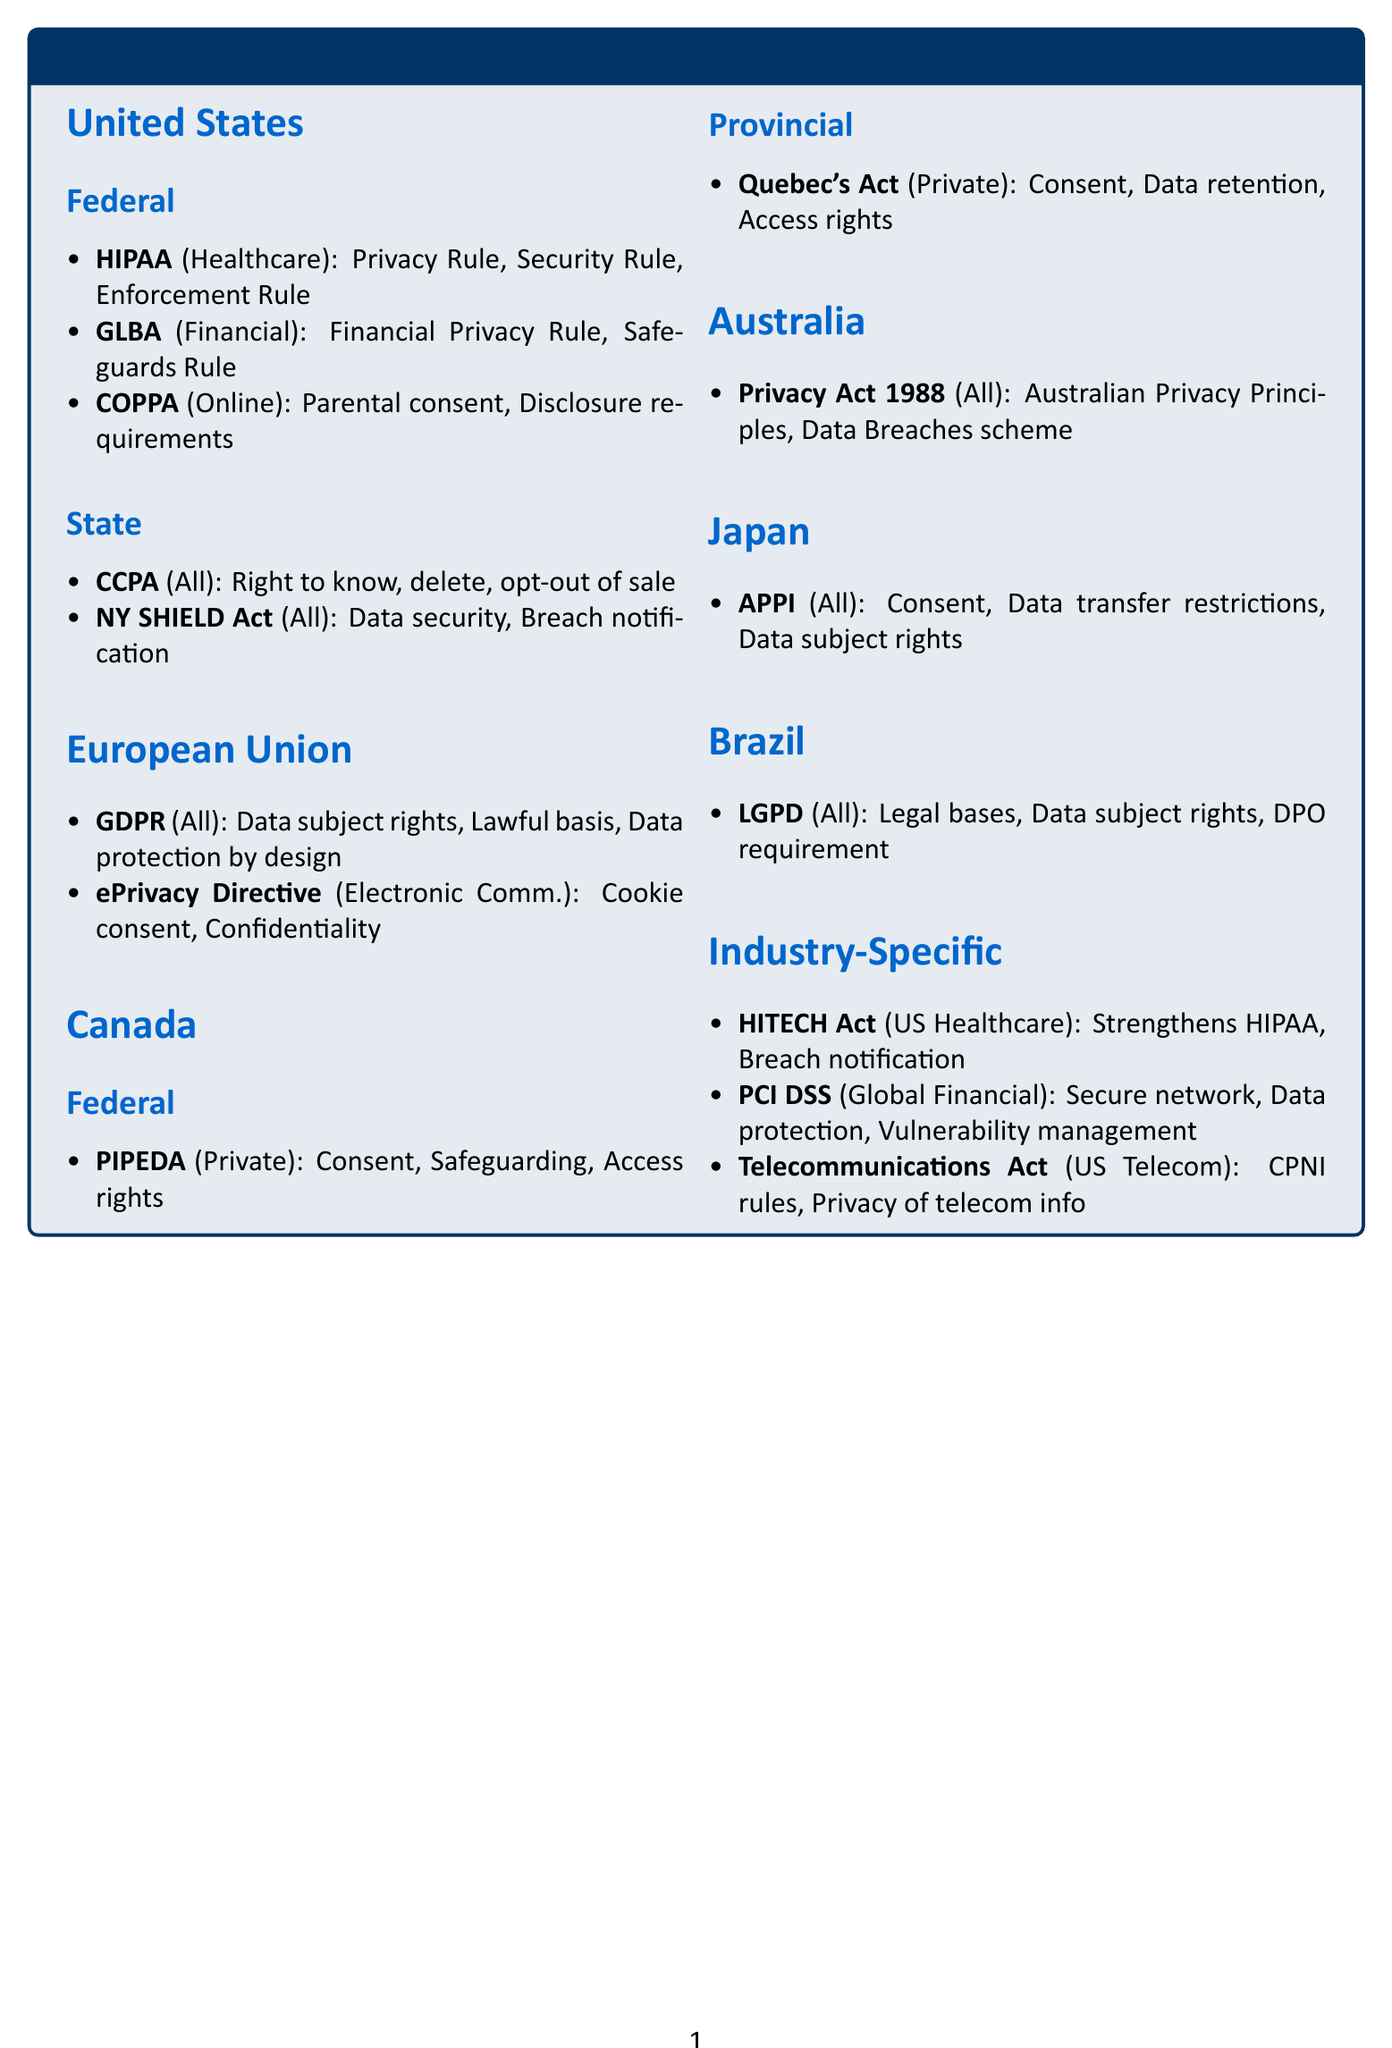what is the full name of HIPAA? The document lists the full name of HIPAA as the Health Insurance Portability and Accountability Act.
Answer: Health Insurance Portability and Accountability Act which law includes rights to know, delete, and opt-out of sale? These key provisions are specified under the California Consumer Privacy Act mentioned in the document.
Answer: California Consumer Privacy Act how many key provisions does the GDPR have? The document outlines three key provisions under GDPR, including data subject rights and lawful basis for processing.
Answer: Three which act strengthens HIPAA enforcement? The document mentions the HITECH Act as an act that strengthens the enforcement of HIPAA in the healthcare sector.
Answer: HITECH Act what sector does PIPEDA apply to? The directory indicates that PIPEDA applies specifically to the private sector in Canada.
Answer: Private Sector what jurisdiction does the ePrivacy Directive apply to? The document specifies that the ePrivacy Directive applies within the European Union jurisdiction.
Answer: European Union which law requires parental consent for children's data? The Children's Online Privacy Protection Act is the law that requires parental consent for the collection of children's data.
Answer: Children’s Online Privacy Protection Act how many provinces have specific laws mentioned in Canada? The document specifies laws at two levels: federal and provincial, noting that Quebec has its own specific law.
Answer: Two what is the primary focus of the PCI DSS? The document outlines that the PCI DSS focuses on secure network architecture and cardholder data protection in the financial sector.
Answer: Secure network architecture and cardholder data protection 